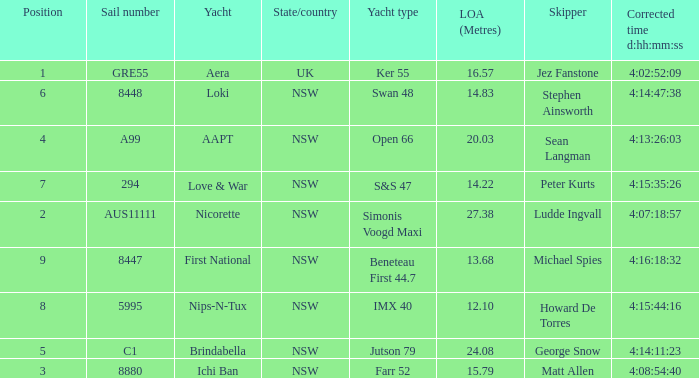What is the ranking for NSW open 66 racing boat.  4.0. 